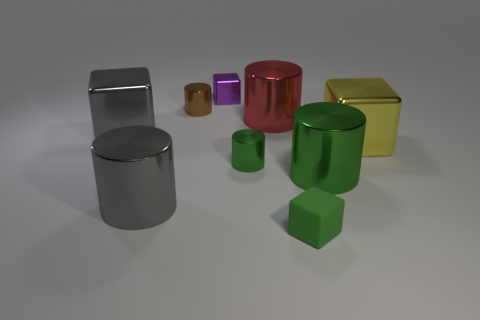Are there fewer small green blocks that are to the right of the small matte object than gray blocks behind the big red shiny cylinder?
Your answer should be compact. No. What is the shape of the large gray metallic thing behind the big gray thing that is on the right side of the gray shiny block?
Keep it short and to the point. Cube. What number of other objects are the same material as the gray block?
Offer a terse response. 7. Is there any other thing that is the same size as the green rubber thing?
Your answer should be compact. Yes. Are there more blue shiny cylinders than gray metal cylinders?
Make the answer very short. No. What is the size of the metal cylinder that is to the right of the cube that is in front of the large block that is right of the gray metallic cylinder?
Give a very brief answer. Large. There is a red cylinder; does it have the same size as the gray thing behind the gray shiny cylinder?
Your response must be concise. Yes. Is the number of large shiny things that are to the left of the brown cylinder less than the number of tiny purple cubes?
Provide a short and direct response. No. How many small cylinders are the same color as the tiny shiny cube?
Your response must be concise. 0. Is the number of small things less than the number of things?
Your answer should be very brief. Yes. 